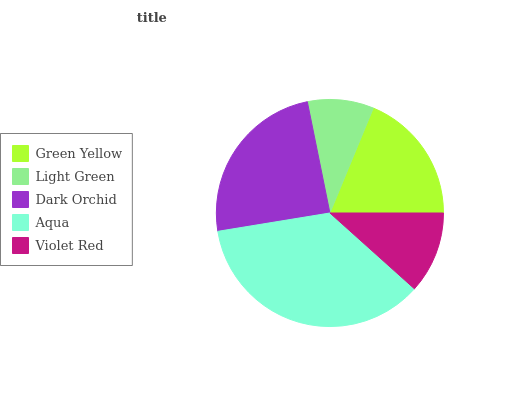Is Light Green the minimum?
Answer yes or no. Yes. Is Aqua the maximum?
Answer yes or no. Yes. Is Dark Orchid the minimum?
Answer yes or no. No. Is Dark Orchid the maximum?
Answer yes or no. No. Is Dark Orchid greater than Light Green?
Answer yes or no. Yes. Is Light Green less than Dark Orchid?
Answer yes or no. Yes. Is Light Green greater than Dark Orchid?
Answer yes or no. No. Is Dark Orchid less than Light Green?
Answer yes or no. No. Is Green Yellow the high median?
Answer yes or no. Yes. Is Green Yellow the low median?
Answer yes or no. Yes. Is Light Green the high median?
Answer yes or no. No. Is Dark Orchid the low median?
Answer yes or no. No. 